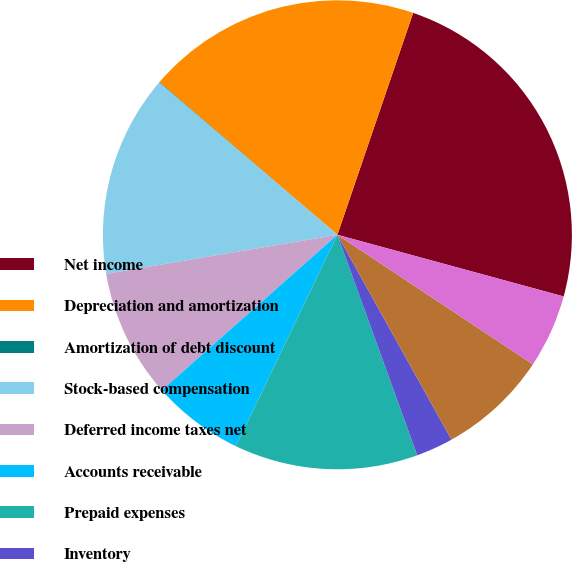<chart> <loc_0><loc_0><loc_500><loc_500><pie_chart><fcel>Net income<fcel>Depreciation and amortization<fcel>Amortization of debt discount<fcel>Stock-based compensation<fcel>Deferred income taxes net<fcel>Accounts receivable<fcel>Prepaid expenses<fcel>Inventory<fcel>Deposits and other assets<fcel>Accounts payable<nl><fcel>24.0%<fcel>18.95%<fcel>0.04%<fcel>13.91%<fcel>8.87%<fcel>6.34%<fcel>12.65%<fcel>2.56%<fcel>7.6%<fcel>5.08%<nl></chart> 